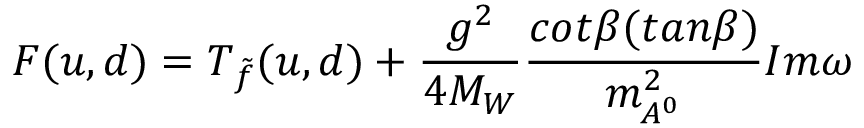Convert formula to latex. <formula><loc_0><loc_0><loc_500><loc_500>F ( u , d ) = T _ { \tilde { f } } ( u , d ) + \frac { g ^ { 2 } } { 4 M _ { W } } \frac { c o t \beta ( t a n \beta ) } { m _ { A ^ { 0 } } ^ { 2 } } I m \omega</formula> 